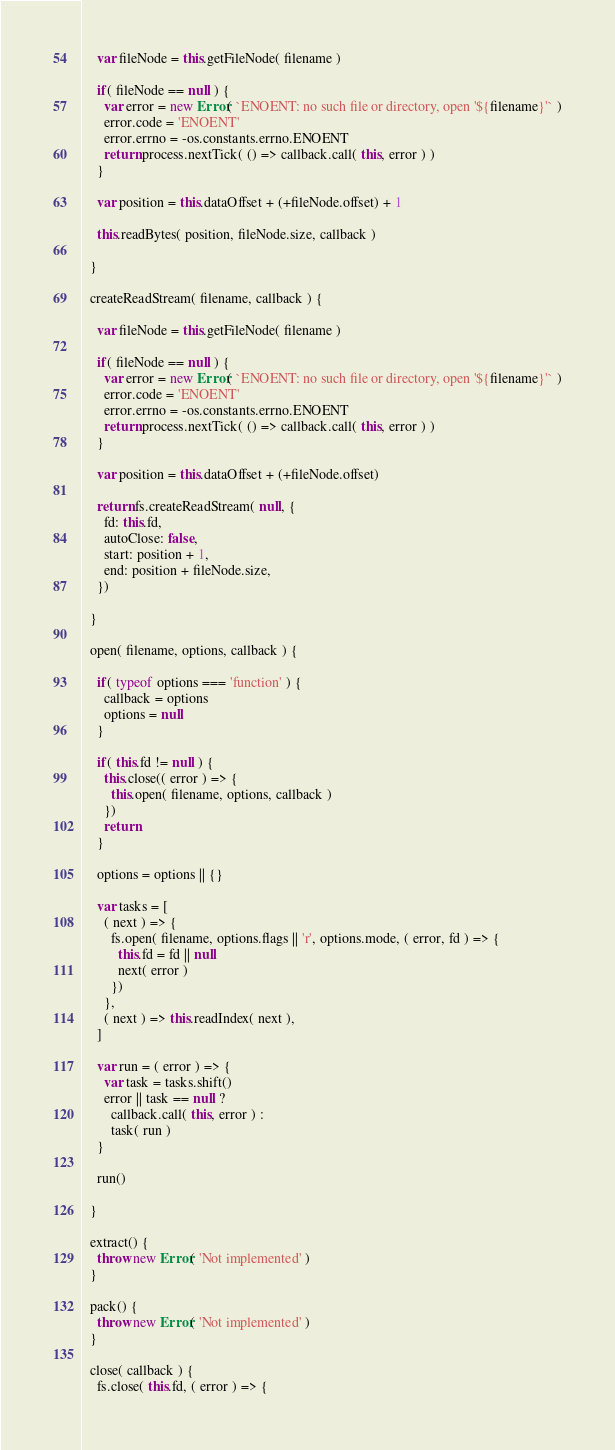<code> <loc_0><loc_0><loc_500><loc_500><_JavaScript_>
    var fileNode = this.getFileNode( filename )

    if( fileNode == null ) {
      var error = new Error( `ENOENT: no such file or directory, open '${filename}'` )
      error.code = 'ENOENT'
      error.errno = -os.constants.errno.ENOENT
      return process.nextTick( () => callback.call( this, error ) )
    }

    var position = this.dataOffset + (+fileNode.offset) + 1

    this.readBytes( position, fileNode.size, callback )

  }

  createReadStream( filename, callback ) {

    var fileNode = this.getFileNode( filename )

    if( fileNode == null ) {
      var error = new Error( `ENOENT: no such file or directory, open '${filename}'` )
      error.code = 'ENOENT'
      error.errno = -os.constants.errno.ENOENT
      return process.nextTick( () => callback.call( this, error ) )
    }

    var position = this.dataOffset + (+fileNode.offset)

    return fs.createReadStream( null, {
      fd: this.fd,
      autoClose: false,
      start: position + 1,
      end: position + fileNode.size,
    })

  }

  open( filename, options, callback ) {

    if( typeof options === 'function' ) {
      callback = options
      options = null
    }

    if( this.fd != null ) {
      this.close(( error ) => {
        this.open( filename, options, callback )
      })
      return
    }

    options = options || {}

    var tasks = [
      ( next ) => {
        fs.open( filename, options.flags || 'r', options.mode, ( error, fd ) => {
          this.fd = fd || null
          next( error )
        })
      },
      ( next ) => this.readIndex( next ),
    ]

    var run = ( error ) => {
      var task = tasks.shift()
      error || task == null ?
        callback.call( this, error ) :
        task( run )
    }

    run()

  }

  extract() {
    throw new Error( 'Not implemented' )
  }

  pack() {
    throw new Error( 'Not implemented' )
  }

  close( callback ) {
    fs.close( this.fd, ( error ) => {</code> 